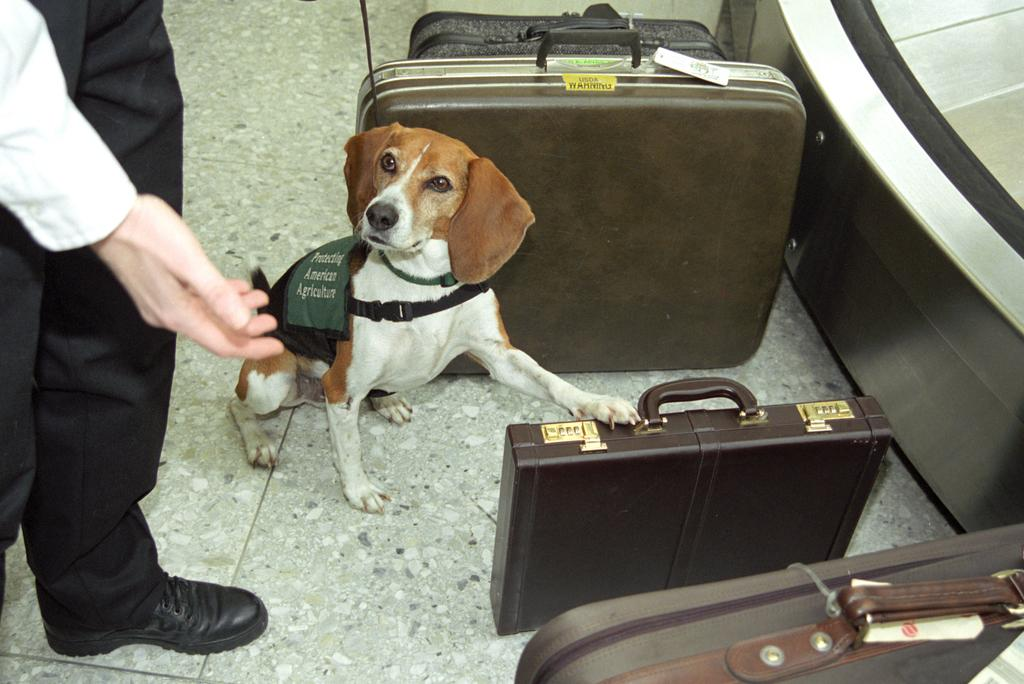What is the main subject in the center of the image? There is a dog in the center of the image. Who is standing on the left side of the image? There is a man standing on the left side of the image. What objects are on the right side of the image? There are briefcases on the right side of the image. Where are the briefcases placed in the image? The briefcases are placed on the floor. What type of prose is being recited by the dog in the image? There is no indication in the image that the dog is reciting any prose. What type of connection can be seen between the man and the dog in the image? The image does not show any specific connection between the man and the dog. 